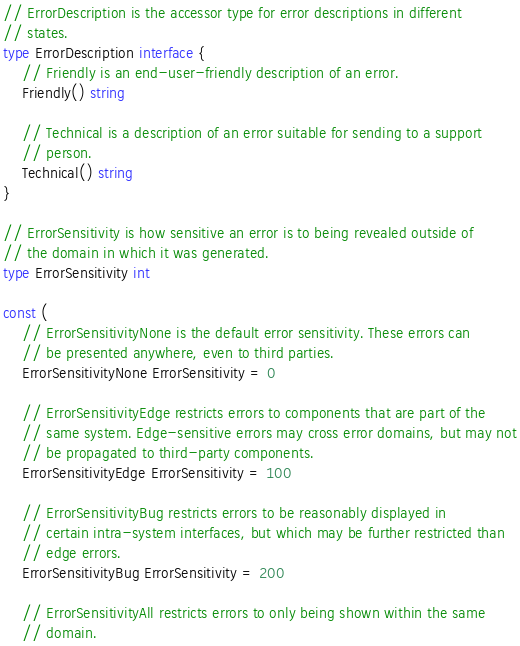<code> <loc_0><loc_0><loc_500><loc_500><_Go_>// ErrorDescription is the accessor type for error descriptions in different
// states.
type ErrorDescription interface {
	// Friendly is an end-user-friendly description of an error.
	Friendly() string

	// Technical is a description of an error suitable for sending to a support
	// person.
	Technical() string
}

// ErrorSensitivity is how sensitive an error is to being revealed outside of
// the domain in which it was generated.
type ErrorSensitivity int

const (
	// ErrorSensitivityNone is the default error sensitivity. These errors can
	// be presented anywhere, even to third parties.
	ErrorSensitivityNone ErrorSensitivity = 0

	// ErrorSensitivityEdge restricts errors to components that are part of the
	// same system. Edge-sensitive errors may cross error domains, but may not
	// be propagated to third-party components.
	ErrorSensitivityEdge ErrorSensitivity = 100

	// ErrorSensitivityBug restricts errors to be reasonably displayed in
	// certain intra-system interfaces, but which may be further restricted than
	// edge errors.
	ErrorSensitivityBug ErrorSensitivity = 200

	// ErrorSensitivityAll restricts errors to only being shown within the same
	// domain.</code> 